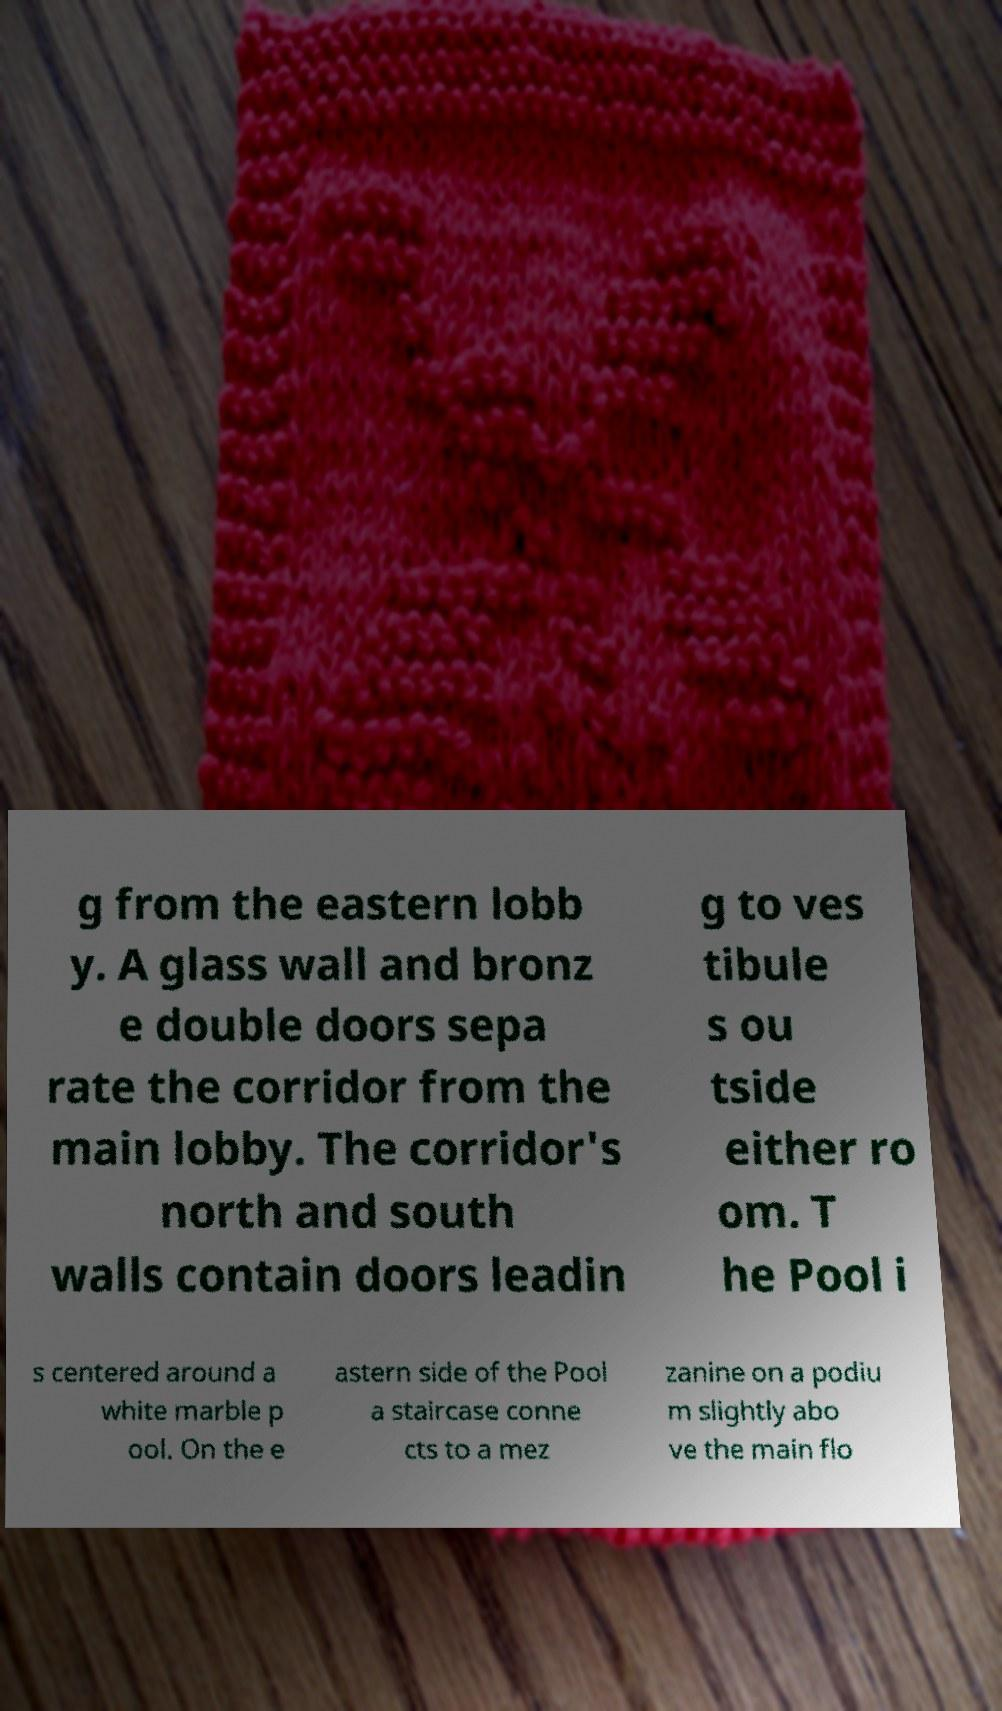I need the written content from this picture converted into text. Can you do that? g from the eastern lobb y. A glass wall and bronz e double doors sepa rate the corridor from the main lobby. The corridor's north and south walls contain doors leadin g to ves tibule s ou tside either ro om. T he Pool i s centered around a white marble p ool. On the e astern side of the Pool a staircase conne cts to a mez zanine on a podiu m slightly abo ve the main flo 